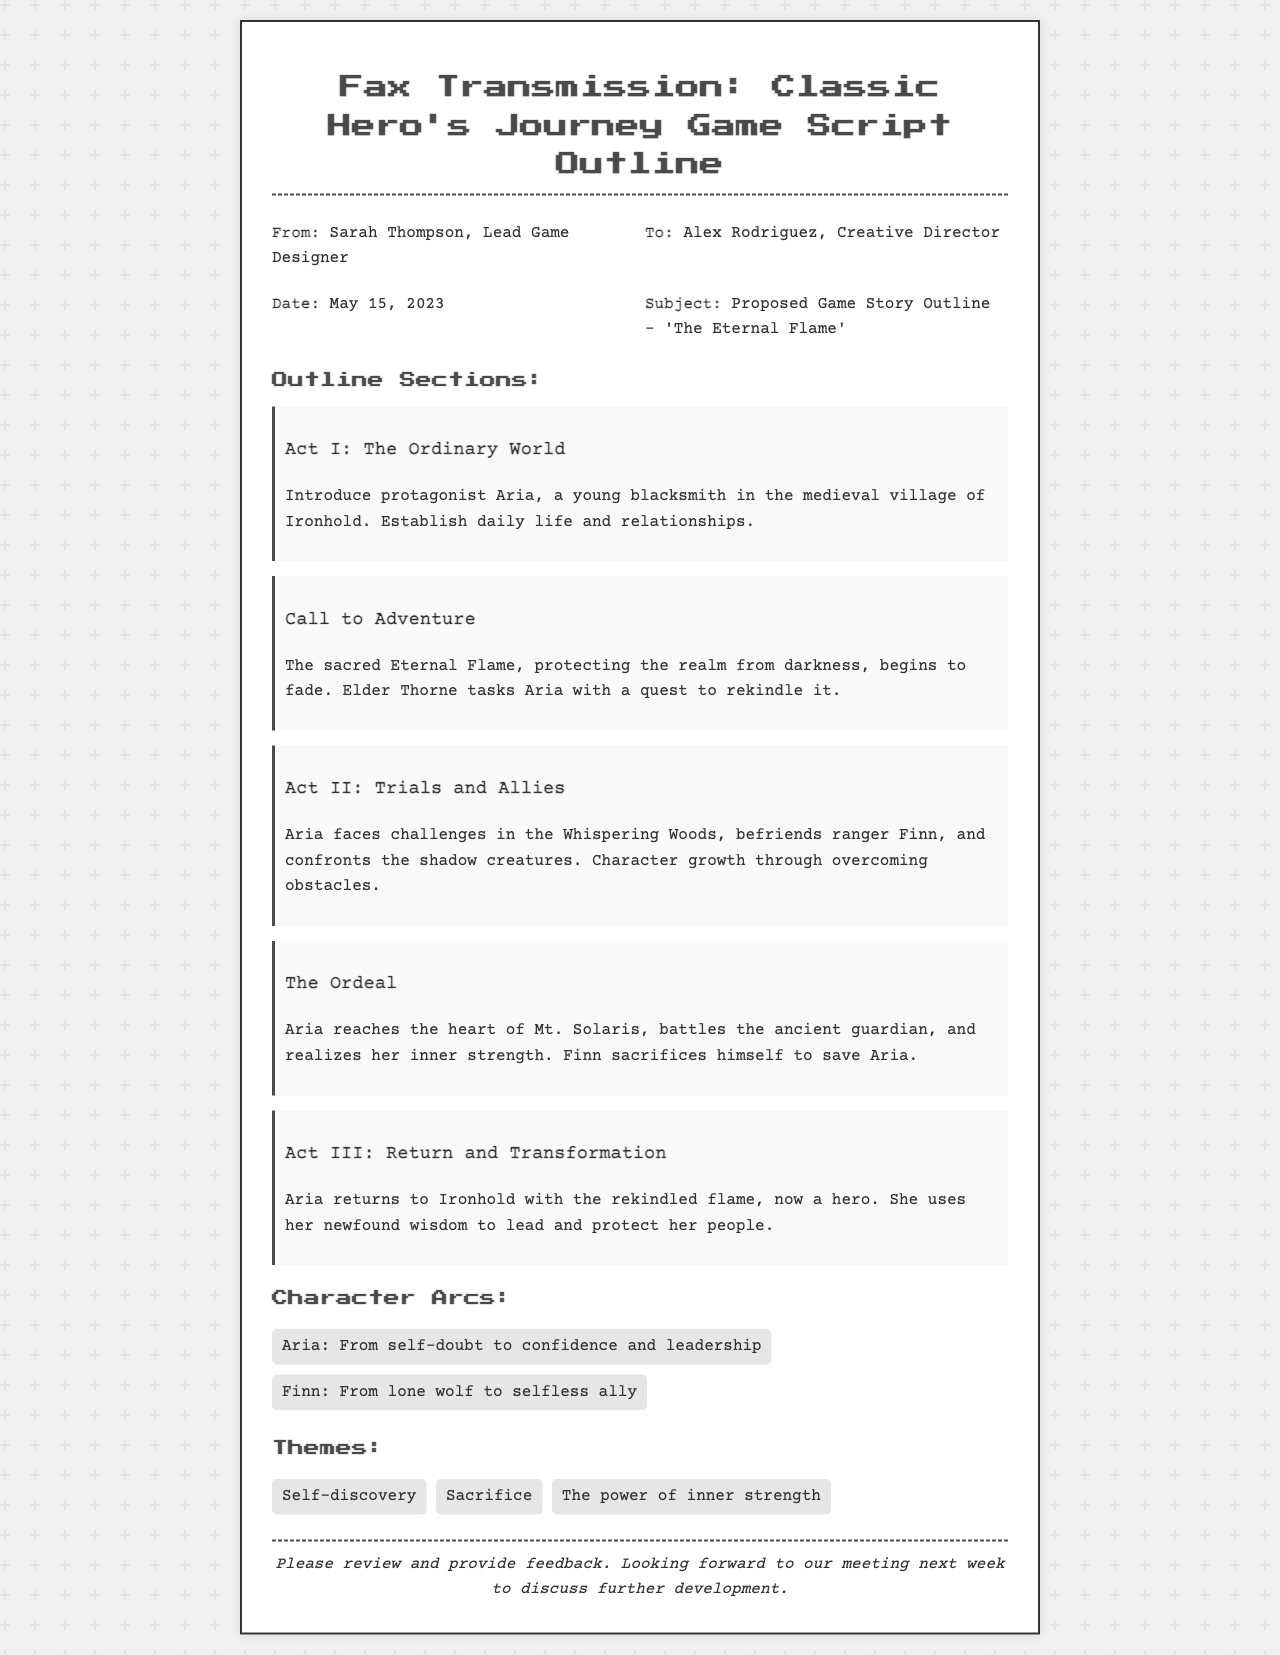What is the title of the proposed game? The title is stated in the subject line of the fax as 'The Eternal Flame'.
Answer: 'The Eternal Flame' Who is the protagonist of the game? The protagonist is introduced in Act I as Aria, a young blacksmith.
Answer: Aria What date was the fax sent? The date is specified in the header of the fax document as May 15, 2023.
Answer: May 15, 2023 What is the name of the elder who tasks Aria with the quest? The elder who gives Aria her task is named Elder Thorne.
Answer: Elder Thorne What significant event triggers Aria's quest? The trigger for Aria's quest is the fading of the sacred Eternal Flame.
Answer: Fading of the sacred Eternal Flame In which location does Aria confront the ancient guardian? The document states that Aria confronts the guardian in the heart of Mt. Solaris.
Answer: Mt. Solaris What character arc does Finn undergo? Finn's character arc is described as moving from a lone wolf to a selfless ally.
Answer: From lone wolf to selfless ally What theme involves personal growth? The theme discussing personal growth is self-discovery, as indicated in the themes section.
Answer: Self-discovery What is the main genre setting of the game? The setting, as inferred from the character and plot descriptions, is a medieval village.
Answer: Medieval village 